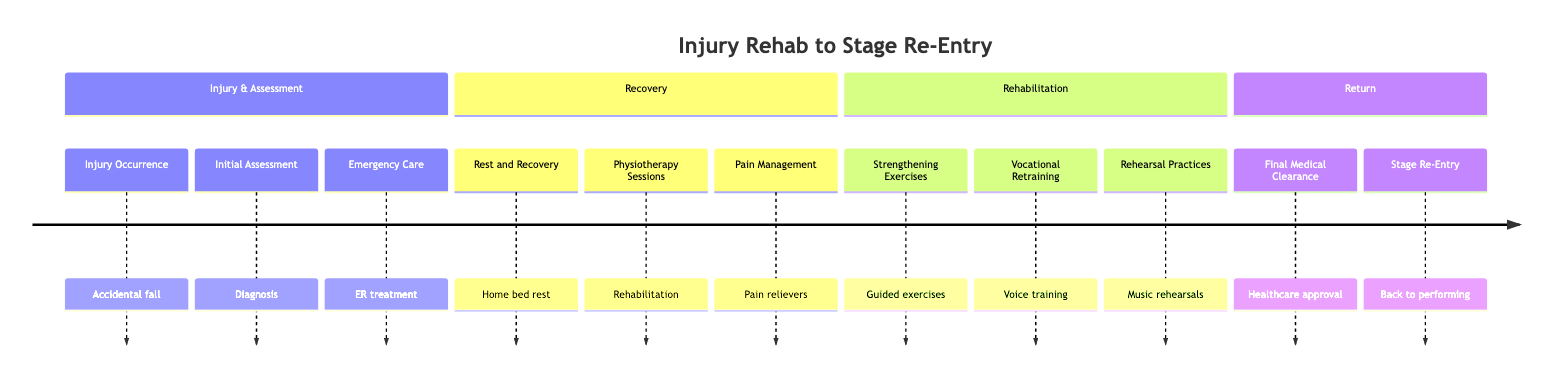What is the first stage in the clinical pathway? The first stage listed in the diagram is "Injury Occurrence," which details the event of an accidental fall during a performance.
Answer: Injury Occurrence How many stages are there in total? By counting the number of stages listed in the diagram, I see there are 11 stages overall, from "Injury Occurrence" to "Stage Re-Entry."
Answer: 11 What icon represents the Physiotherapy Sessions stage? The "Physiotherapy Sessions" stage is illustrated with the icon of "physical therapy," which indicates the nature of this step in the rehabilitation process.
Answer: physical therapy Which stage involves getting approval from a healthcare provider? The stage that requires approval from a healthcare provider is "Final Medical Clearance," which is crucial before resuming performance.
Answer: Final Medical Clearance Which two stages directly precede "Stage Re-Entry"? The two stages that come before "Stage Re-Entry" in the pathway are "Final Medical Clearance" and "Rehearsal Practices," signifying the final preparations before returning to the stage.
Answer: Final Medical Clearance and Rehearsal Practices What stage includes voice and posture training? The stage that encompasses voice and posture training is "Vocational Retraining," as it focuses on preparing the artist for performance.
Answer: Vocational Retraining How is pain managed during the recovery phase? Pain management during the recovery phase is handled through the "Pain Management" stage, which involves prescription pain relievers.
Answer: Pain Management What is the significance of the "Strengthening Exercises" stage? The "Strengthening Exercises" stage is significant because it involves guided exercises provided by a physiotherapist to help restore strength essential for performing.
Answer: Strengthening Exercises What follows "Physiotherapy Sessions" in the recovery section? Following "Physiotherapy Sessions," the next stage in the recovery section is "Pain Management," indicating the process of addressing pain post-therapy.
Answer: Pain Management What icon represents the final step of returning to the stage? The final step of returning to the stage, "Stage Re-Entry," is represented with the icon of a "stage," highlighting the culmination of the rehabilitation process.
Answer: stage 